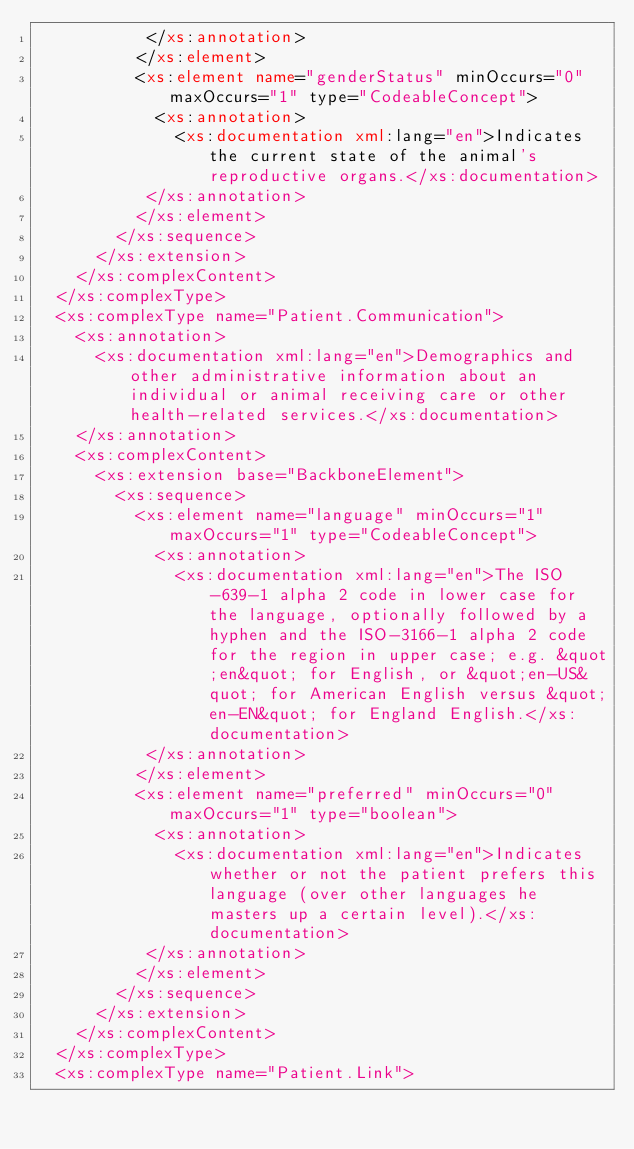<code> <loc_0><loc_0><loc_500><loc_500><_XML_>           </xs:annotation>
          </xs:element>
          <xs:element name="genderStatus" minOccurs="0" maxOccurs="1" type="CodeableConcept">
            <xs:annotation>
              <xs:documentation xml:lang="en">Indicates the current state of the animal's reproductive organs.</xs:documentation>
           </xs:annotation>
          </xs:element>
        </xs:sequence>
      </xs:extension>
    </xs:complexContent>
  </xs:complexType>
  <xs:complexType name="Patient.Communication">
    <xs:annotation>
      <xs:documentation xml:lang="en">Demographics and other administrative information about an individual or animal receiving care or other health-related services.</xs:documentation>
    </xs:annotation>
    <xs:complexContent>
      <xs:extension base="BackboneElement">
        <xs:sequence>
          <xs:element name="language" minOccurs="1" maxOccurs="1" type="CodeableConcept">
            <xs:annotation>
              <xs:documentation xml:lang="en">The ISO-639-1 alpha 2 code in lower case for the language, optionally followed by a hyphen and the ISO-3166-1 alpha 2 code for the region in upper case; e.g. &quot;en&quot; for English, or &quot;en-US&quot; for American English versus &quot;en-EN&quot; for England English.</xs:documentation>
           </xs:annotation>
          </xs:element>
          <xs:element name="preferred" minOccurs="0" maxOccurs="1" type="boolean">
            <xs:annotation>
              <xs:documentation xml:lang="en">Indicates whether or not the patient prefers this language (over other languages he masters up a certain level).</xs:documentation>
           </xs:annotation>
          </xs:element>
        </xs:sequence>
      </xs:extension>
    </xs:complexContent>
  </xs:complexType>
  <xs:complexType name="Patient.Link"></code> 